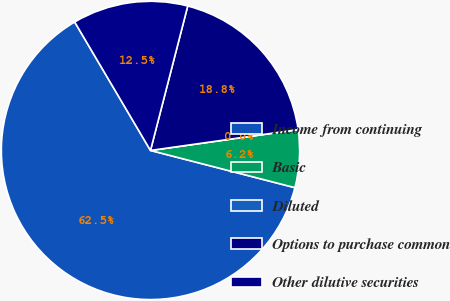Convert chart to OTSL. <chart><loc_0><loc_0><loc_500><loc_500><pie_chart><fcel>Income from continuing<fcel>Basic<fcel>Diluted<fcel>Options to purchase common<fcel>Other dilutive securities<nl><fcel>62.5%<fcel>6.25%<fcel>0.0%<fcel>18.75%<fcel>12.5%<nl></chart> 